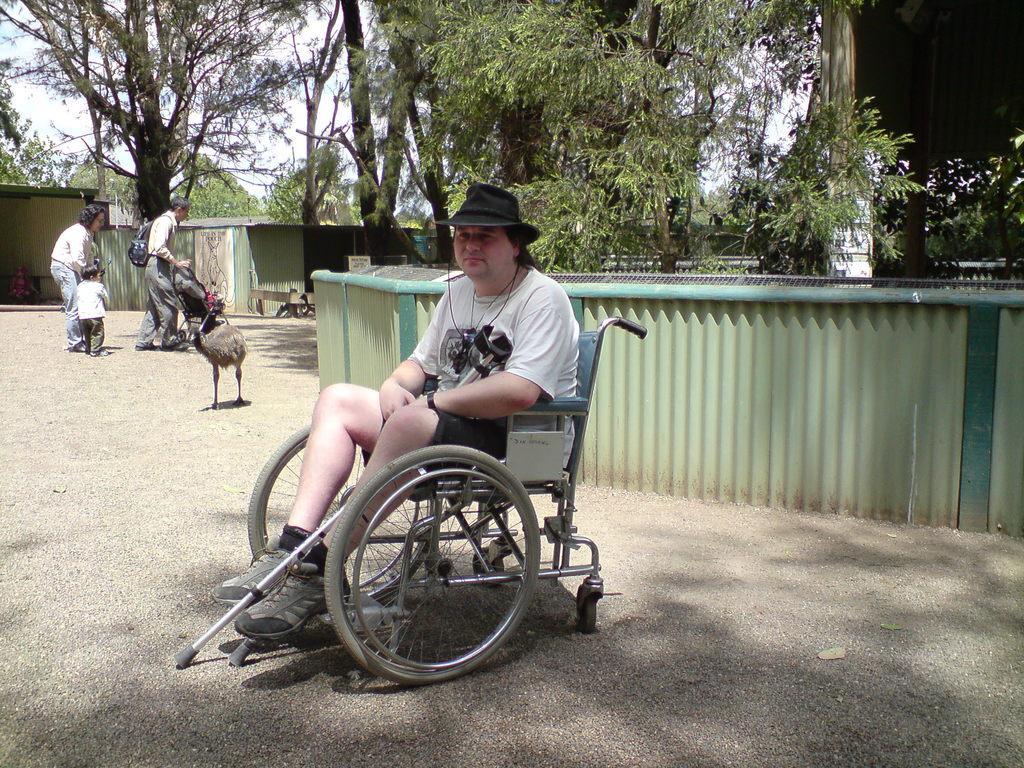In one or two sentences, can you explain what this image depicts? In this image I can see a person is sitting on the wheelchair and holding something. Back I can see trees,fencing,sheds,bird and few people are walking and holding something. 